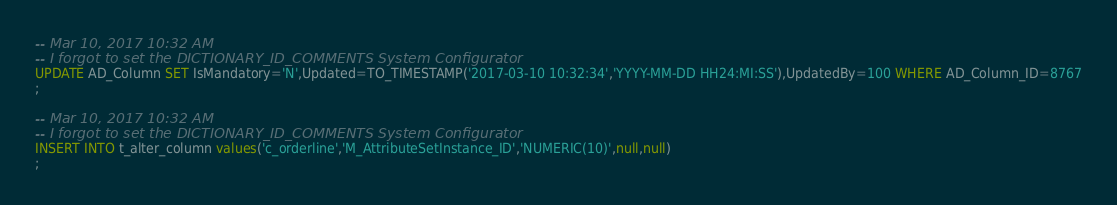<code> <loc_0><loc_0><loc_500><loc_500><_SQL_>-- Mar 10, 2017 10:32 AM
-- I forgot to set the DICTIONARY_ID_COMMENTS System Configurator
UPDATE AD_Column SET IsMandatory='N',Updated=TO_TIMESTAMP('2017-03-10 10:32:34','YYYY-MM-DD HH24:MI:SS'),UpdatedBy=100 WHERE AD_Column_ID=8767
;

-- Mar 10, 2017 10:32 AM
-- I forgot to set the DICTIONARY_ID_COMMENTS System Configurator
INSERT INTO t_alter_column values('c_orderline','M_AttributeSetInstance_ID','NUMERIC(10)',null,null)
;

</code> 